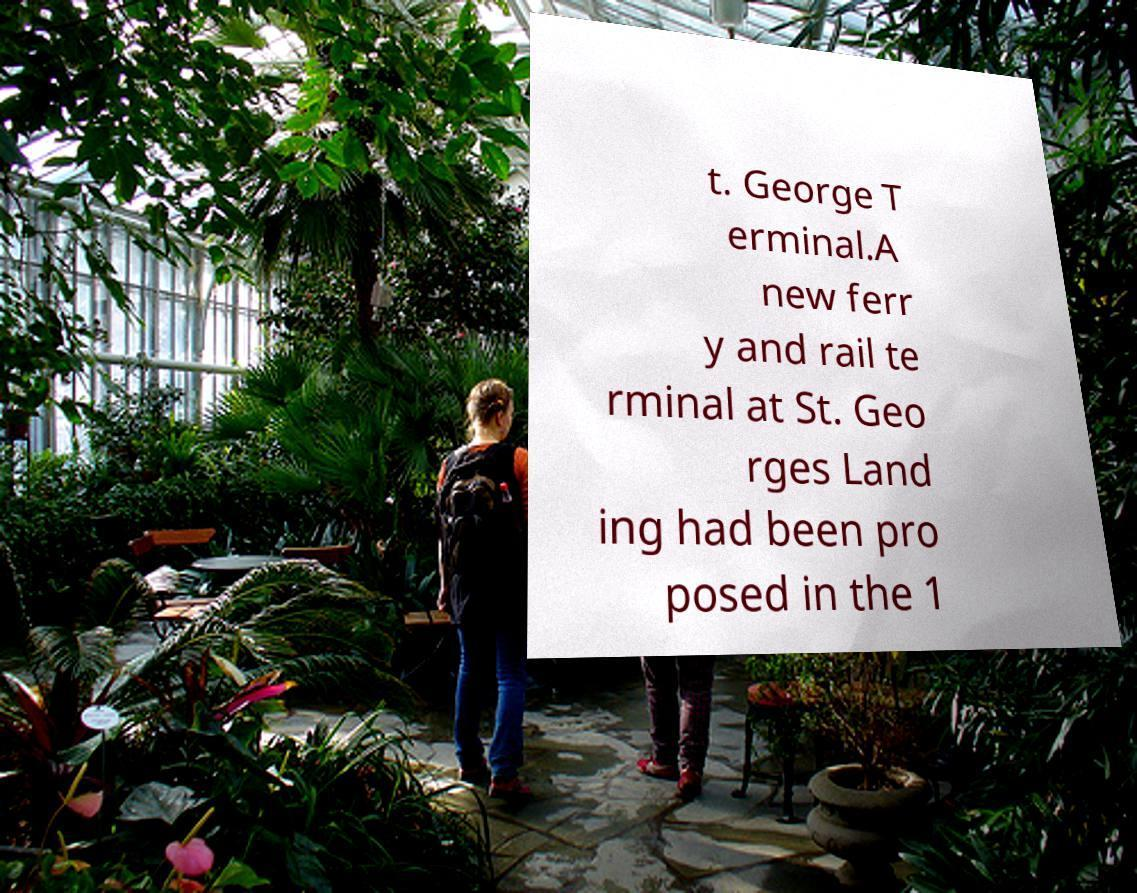For documentation purposes, I need the text within this image transcribed. Could you provide that? t. George T erminal.A new ferr y and rail te rminal at St. Geo rges Land ing had been pro posed in the 1 